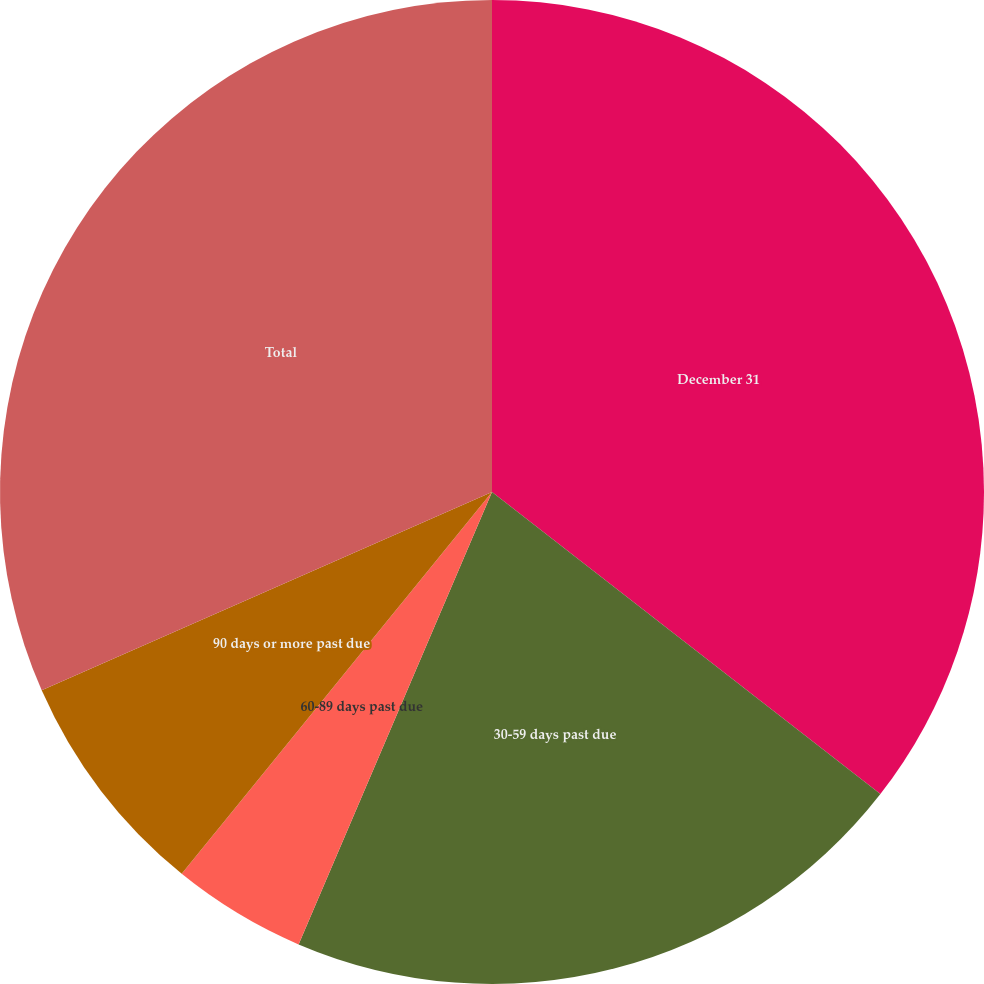Convert chart to OTSL. <chart><loc_0><loc_0><loc_500><loc_500><pie_chart><fcel>December 31<fcel>30-59 days past due<fcel>60-89 days past due<fcel>90 days or more past due<fcel>Total<nl><fcel>35.52%<fcel>20.91%<fcel>4.43%<fcel>7.54%<fcel>31.6%<nl></chart> 